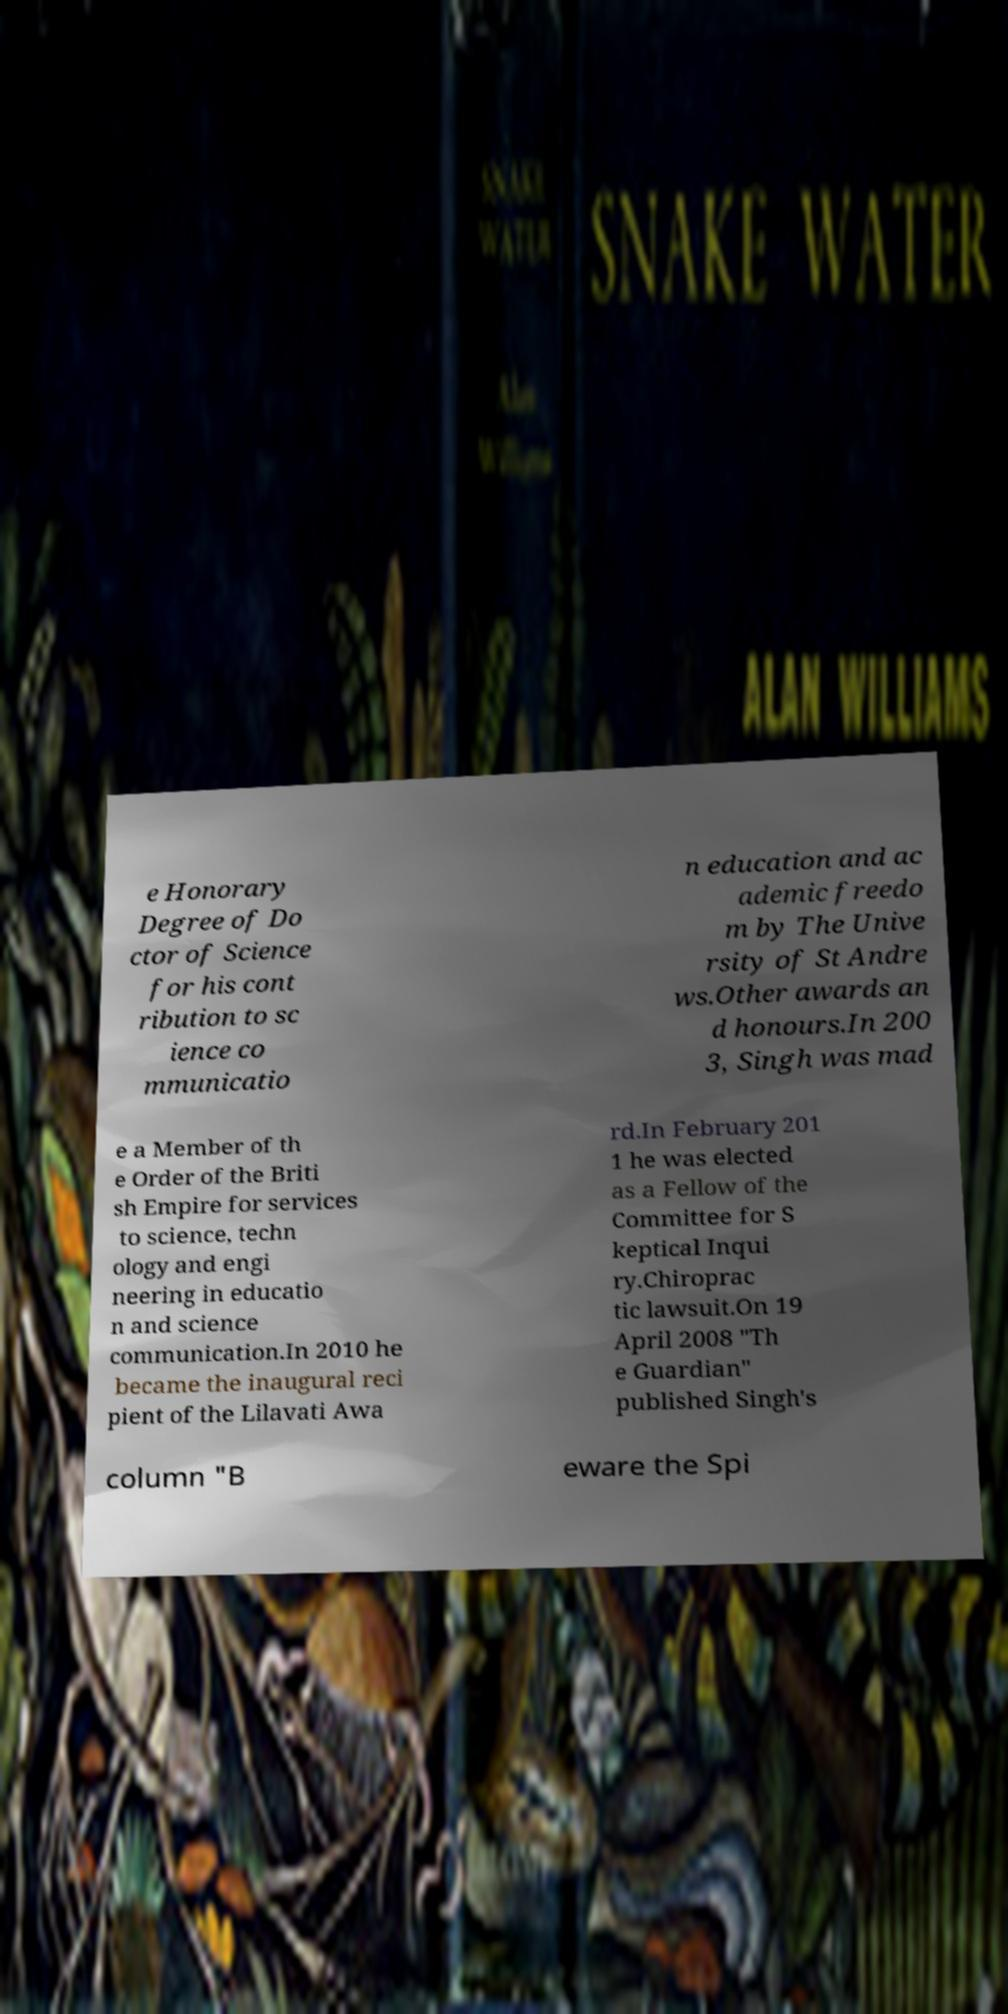Please identify and transcribe the text found in this image. e Honorary Degree of Do ctor of Science for his cont ribution to sc ience co mmunicatio n education and ac ademic freedo m by The Unive rsity of St Andre ws.Other awards an d honours.In 200 3, Singh was mad e a Member of th e Order of the Briti sh Empire for services to science, techn ology and engi neering in educatio n and science communication.In 2010 he became the inaugural reci pient of the Lilavati Awa rd.In February 201 1 he was elected as a Fellow of the Committee for S keptical Inqui ry.Chiroprac tic lawsuit.On 19 April 2008 "Th e Guardian" published Singh's column "B eware the Spi 